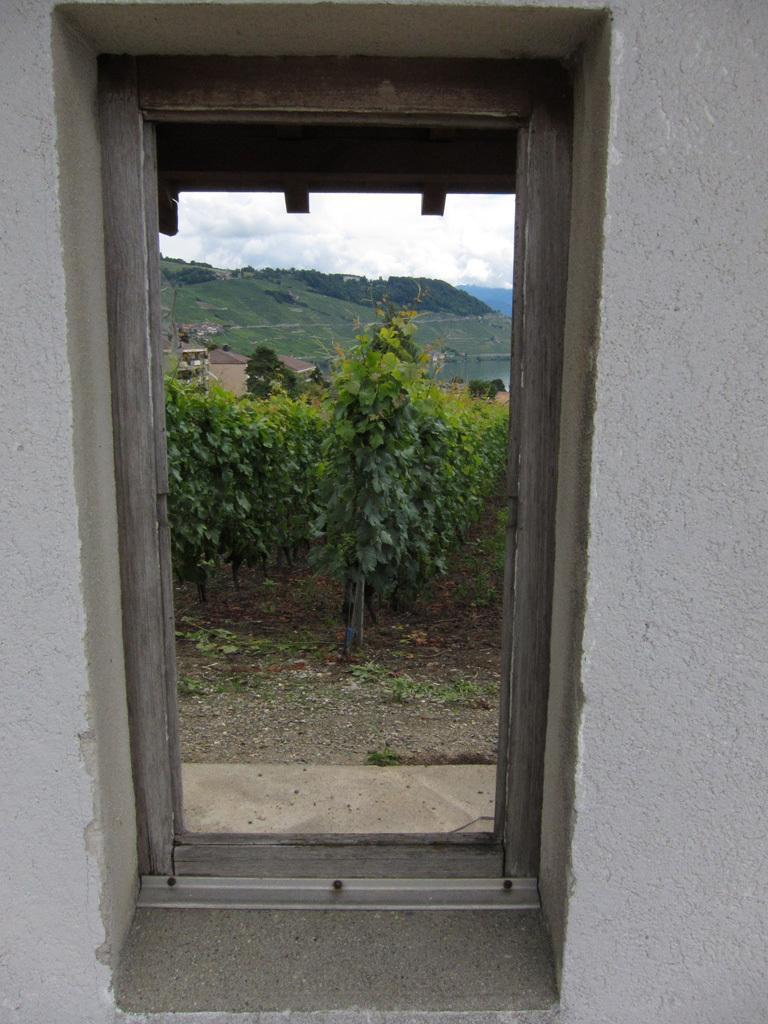Can you describe this image briefly? In the center of the image there is a door. In the background of the image there are mountains and plants. To both the sides of the image there are walls. 